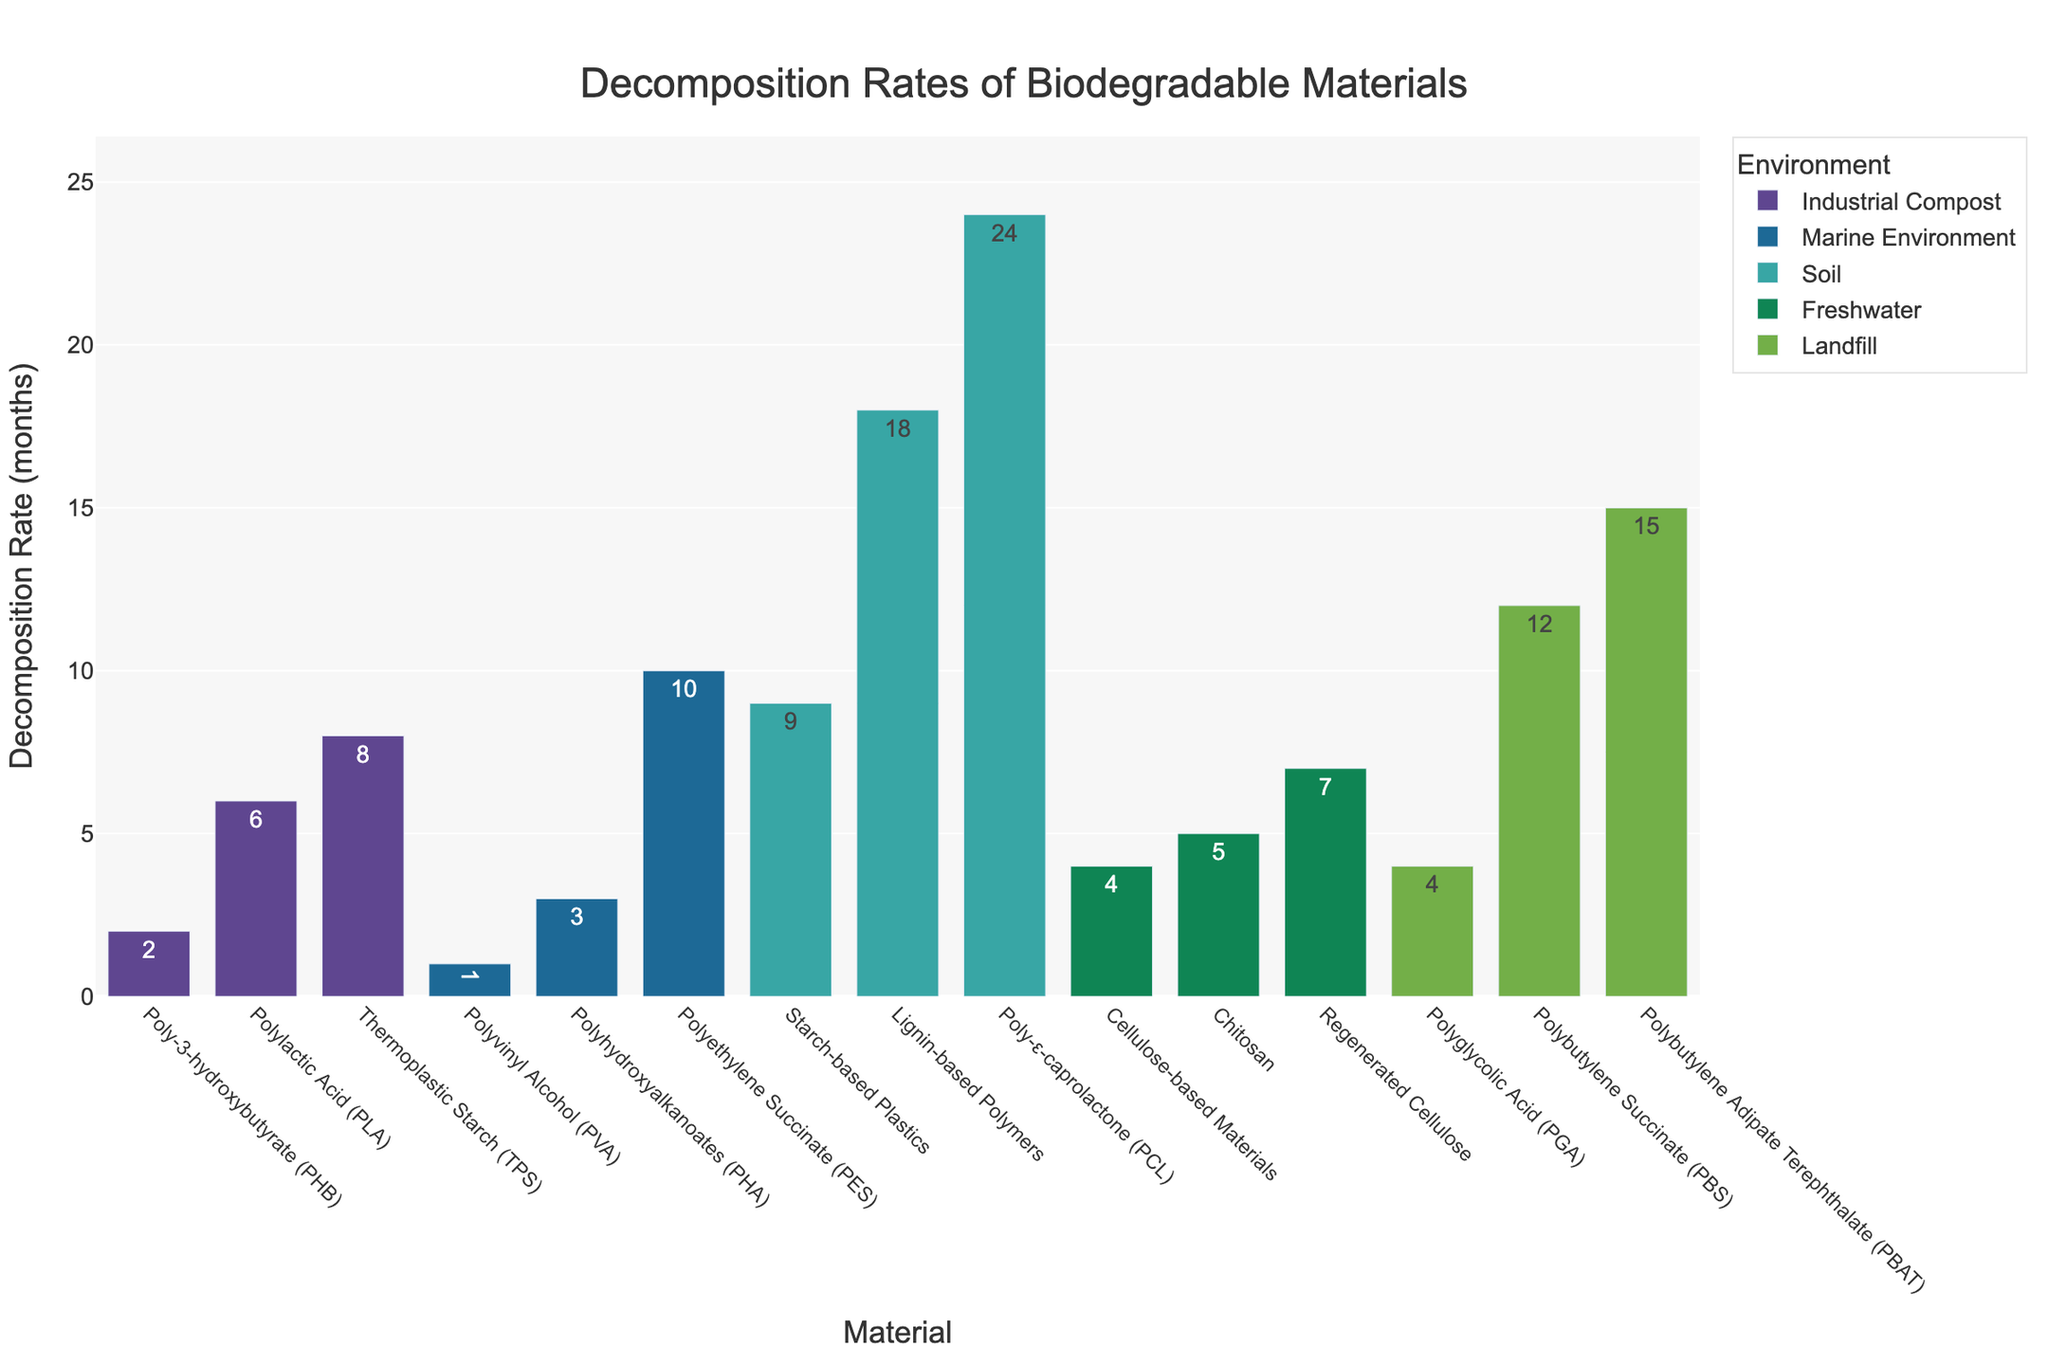Which material has the highest decomposition rate? The highest decomposition rate corresponds to the shortest bar and the lowest value on the y-axis. According to the chart, Polyvinyl Alcohol (PVA) in the Marine Environment decomposes in 1 month, which is the shortest duration.
Answer: Polyvinyl Alcohol (PVA) Which environment has materials with the longest average decomposition rate? To find the average decomposition rate per environment, we need to sum the decomposition rates of materials in each environment and then divide by the number of materials in that environment. After calculation:
- Industrial Compost: (6 + 2 + 8) / 3 = 5.33 months
- Marine Environment: (3 + 1 + 10) / 3 = 4.67 months
- Soil: (9 + 18 + 24) / 3 = 17 months
- Freshwater: (4 + 5 + 7) / 3 = 5.33 months
- Landfill: (12 + 15 + 4) / 3 = 10.33 months
The longest average decomposition rate is for Soil.
Answer: Soil Which material decomposes faster in Industrial Compost: Polylactic Acid (PLA) or Poly-3-hydroxybutyrate (PHB)? Industrial Compost includes PLA and PHB. PLA decomposes in 6 months, while PHB decomposes in 2 months. Comparing these values, PHB decomposes faster.
Answer: Poly-3-hydroxybutyrate (PHB) What is the total decomposition time for all materials in the Freshwater environment? Freshwater environment includes Cellulose-based Materials, Chitosan, and Regenerated Cellulose. Their decomposition times are 4, 5, and 7 months respectively. Summing these values gives 4 + 5 + 7 = 16 months.
Answer: 16 months How does the decomposition rate of Polybutylene Succinate (PBS) in a Landfill compare to Thermoplastic Starch (TPS) in Industrial Compost? PBS decomposes in 12 months in Landfill, while TPS decomposes in 8 months in Industrial Compost. Comparing these values, PBS takes longer to decompose than TPS.
Answer: PBS takes longer Which environment has the most variation in decomposition rates of materials? Variation is identified by looking at the range of decomposition rates within each environment.
- Industrial Compost: 6 - 2 = 4 months
- Marine Environment: 10 - 1 = 9 months
- Soil: 24 - 9 = 15 months
- Freshwater: 7 - 4 = 3 months
- Landfill: 15 - 4 = 11 months
The soil environment shows the greatest range and, hence, the most variation.
Answer: Soil Arrange the materials decomposing in the Marine Environment from quickest to slowest. The materials in the Marine Environment are Polyhydroxyalkanoates (PHA) at 3 months, Polyvinyl Alcohol (PVA) at 1 month, and Polyethylene Succinate (PES) at 10 months. Arranging from quickest to slowest gives: PVA, PHA, PES.
Answer: PVA, PHA, PES 